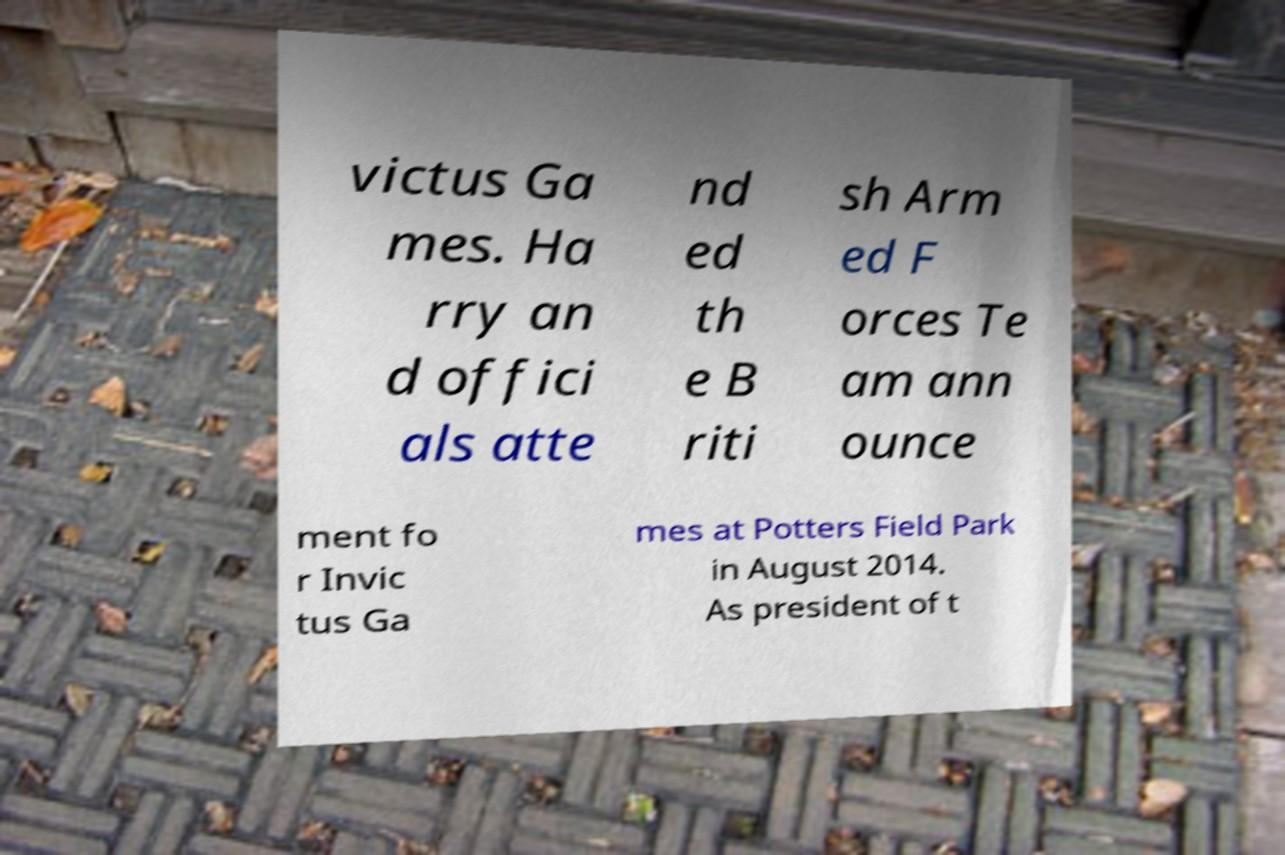There's text embedded in this image that I need extracted. Can you transcribe it verbatim? victus Ga mes. Ha rry an d offici als atte nd ed th e B riti sh Arm ed F orces Te am ann ounce ment fo r Invic tus Ga mes at Potters Field Park in August 2014. As president of t 